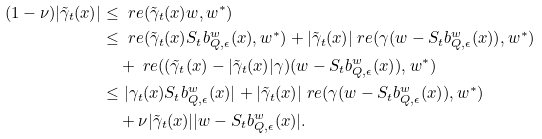<formula> <loc_0><loc_0><loc_500><loc_500>( 1 - \nu ) | \tilde { \gamma } _ { t } ( x ) | & \leq \ r e ( \tilde { \gamma } _ { t } ( x ) w , w ^ { * } ) \\ & \leq \ r e ( \tilde { \gamma } _ { t } ( x ) S _ { t } b _ { Q , \epsilon } ^ { w } ( x ) , w ^ { * } ) + | \tilde { \gamma } _ { t } ( x ) | \ r e ( \gamma ( w - S _ { t } b _ { Q , \epsilon } ^ { w } ( x ) ) , w ^ { * } ) \\ & \quad + \ r e ( ( \tilde { \gamma } _ { t } ( x ) - | \tilde { \gamma } _ { t } ( x ) | \gamma ) ( w - S _ { t } b _ { Q , \epsilon } ^ { w } ( x ) ) , w ^ { * } ) \\ & \leq | \gamma _ { t } ( x ) S _ { t } b _ { Q , \epsilon } ^ { w } ( x ) | + | \tilde { \gamma } _ { t } ( x ) | \ r e ( \gamma ( w - S _ { t } b _ { Q , \epsilon } ^ { w } ( x ) ) , w ^ { * } ) \\ & \quad + \nu | \tilde { \gamma } _ { t } ( x ) | | w - S _ { t } b _ { Q , \epsilon } ^ { w } ( x ) | .</formula> 